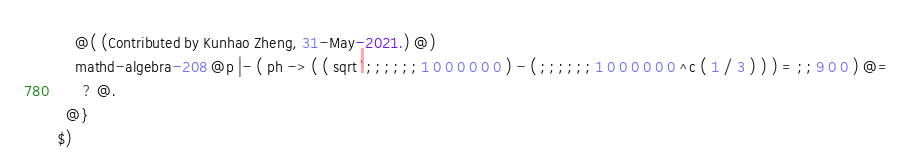Convert code to text. <code><loc_0><loc_0><loc_500><loc_500><_ObjectiveC_>    @( (Contributed by Kunhao Zheng, 31-May-2021.) @)
    mathd-algebra-208 @p |- ( ph -> ( ( sqrt ` ; ; ; ; ; ; 1 0 0 0 0 0 0 ) - ( ; ; ; ; ; ; 1 0 0 0 0 0 0 ^c ( 1 / 3 ) ) ) = ; ; 9 0 0 ) @=
      ? @.
  @}
$)
</code> 